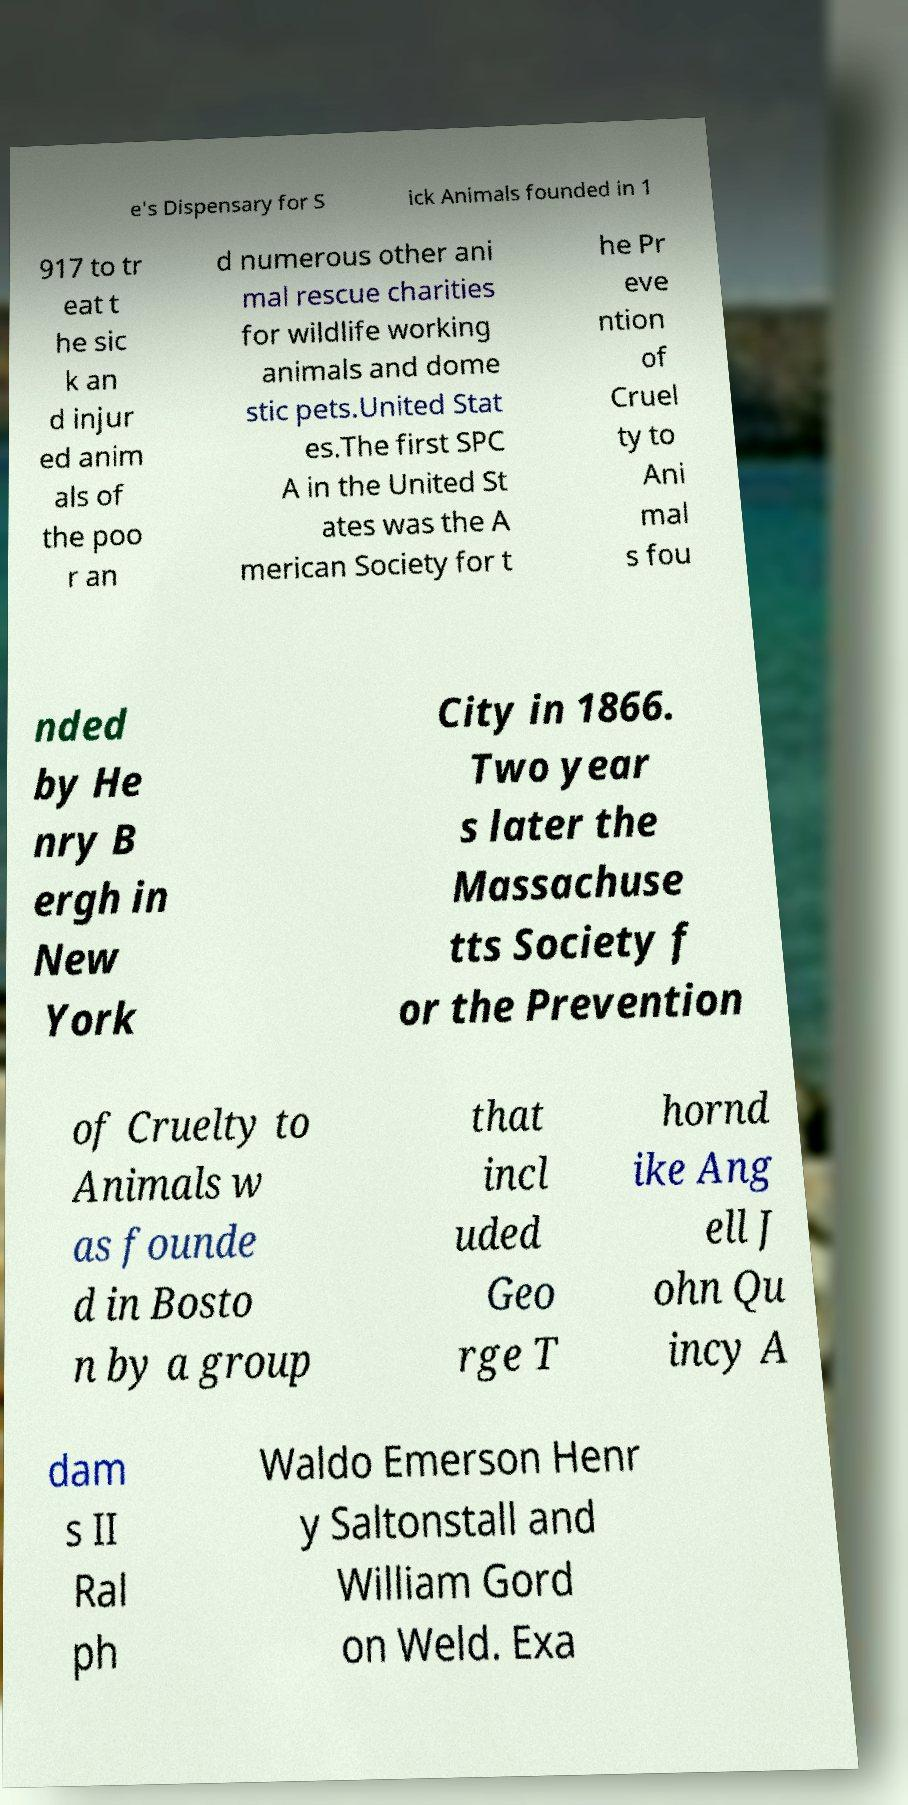I need the written content from this picture converted into text. Can you do that? e's Dispensary for S ick Animals founded in 1 917 to tr eat t he sic k an d injur ed anim als of the poo r an d numerous other ani mal rescue charities for wildlife working animals and dome stic pets.United Stat es.The first SPC A in the United St ates was the A merican Society for t he Pr eve ntion of Cruel ty to Ani mal s fou nded by He nry B ergh in New York City in 1866. Two year s later the Massachuse tts Society f or the Prevention of Cruelty to Animals w as founde d in Bosto n by a group that incl uded Geo rge T hornd ike Ang ell J ohn Qu incy A dam s II Ral ph Waldo Emerson Henr y Saltonstall and William Gord on Weld. Exa 